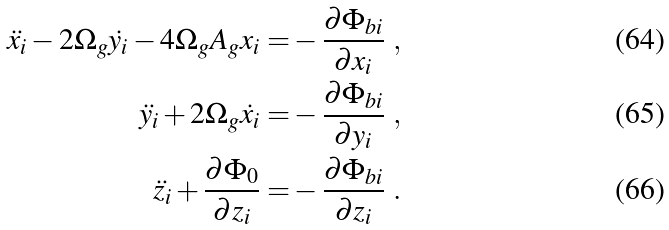Convert formula to latex. <formula><loc_0><loc_0><loc_500><loc_500>\ddot { x _ { i } } - 2 \Omega _ { g } \dot { y _ { i } } - 4 \Omega _ { g } A _ { g } x _ { i } = & - \frac { \partial \Phi _ { b i } } { \partial x _ { i } } \ , \\ \ddot { y _ { i } } + 2 \Omega _ { g } \dot { x _ { i } } = & - \frac { \partial \Phi _ { b i } } { \partial y _ { i } } \ , \\ \ddot { z _ { i } } + \frac { \partial \Phi _ { 0 } } { \partial z _ { i } } = & - \frac { \partial \Phi _ { b i } } { \partial z _ { i } } \ .</formula> 